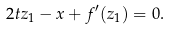<formula> <loc_0><loc_0><loc_500><loc_500>2 t z _ { 1 } - x + f ^ { \prime } ( z _ { 1 } ) = 0 .</formula> 